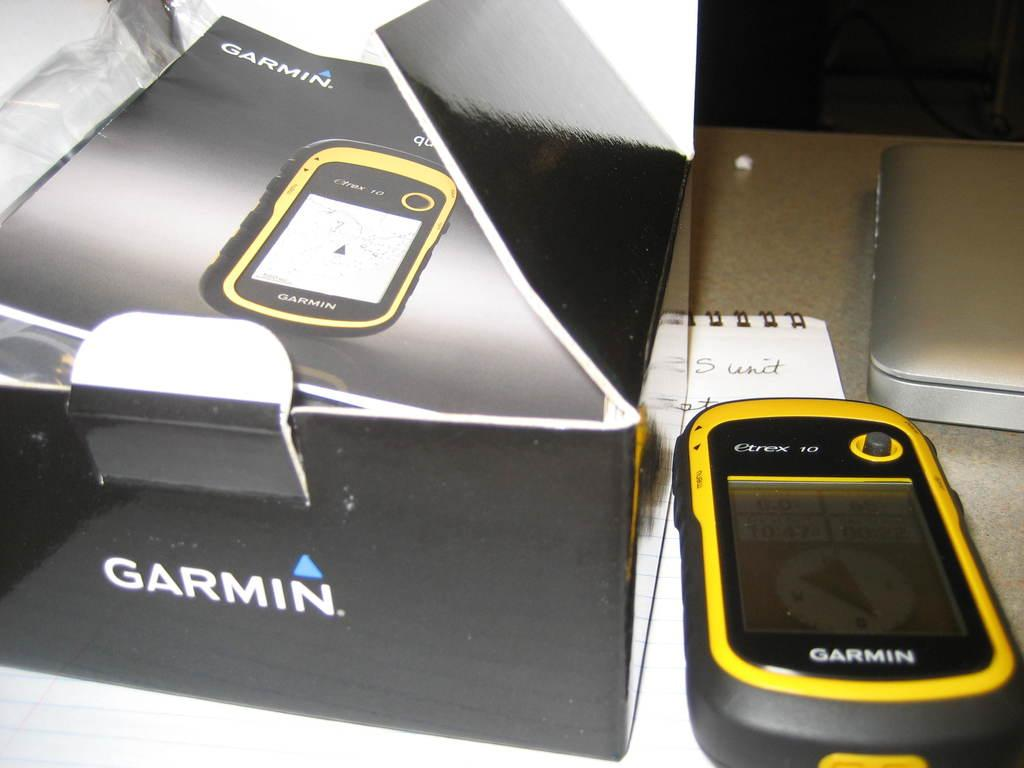<image>
Share a concise interpretation of the image provided. A yellow and black Garmin GPS device and its box. 